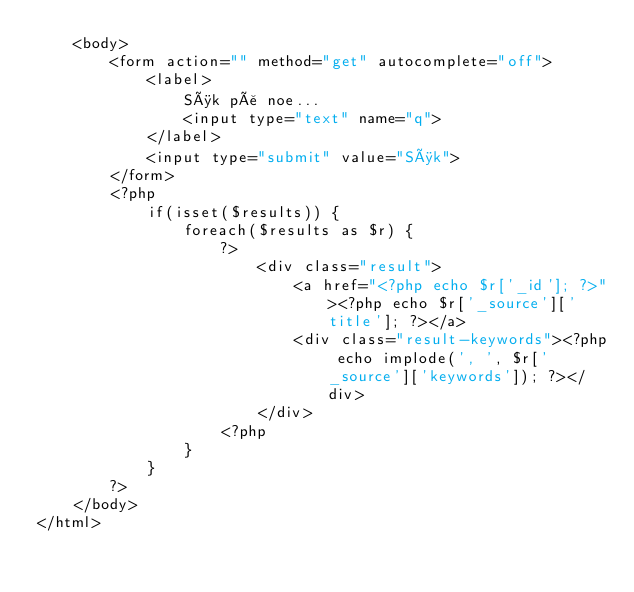Convert code to text. <code><loc_0><loc_0><loc_500><loc_500><_PHP_>    <body>
        <form action="" method="get" autocomplete="off">
            <label>
                Søk på noe...
                <input type="text" name="q">
            </label>
            <input type="submit" value="Søk">
        </form>
        <?php
            if(isset($results)) {
                foreach($results as $r) {
                    ?>
                        <div class="result">
                            <a href="<?php echo $r['_id']; ?>"><?php echo $r['_source']['title']; ?></a>
                            <div class="result-keywords"><?php echo implode(', ', $r['_source']['keywords']); ?></div>
                        </div>
                    <?php
                }
            }
        ?>
    </body>
</html></code> 